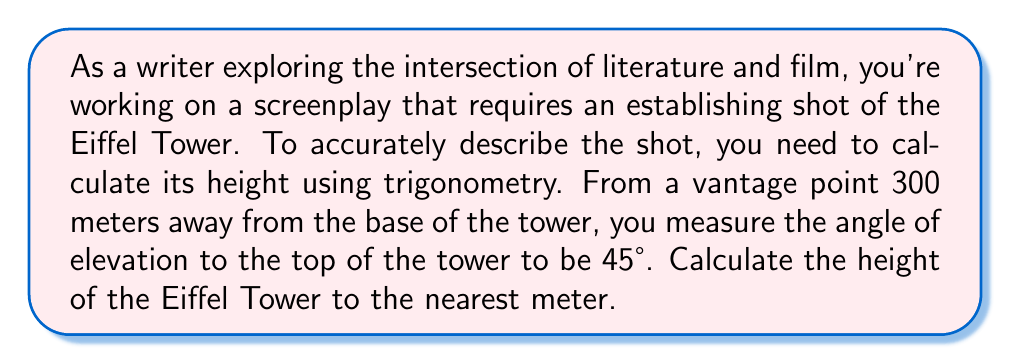Can you answer this question? Let's approach this step-by-step using trigonometry:

1) First, let's visualize the problem:

[asy]
unitsize(0.01cm);
draw((0,0)--(300,0)--(300,300)--(0,0),black);
draw((0,0)--(0,300),dashed);
label("300 m", (150,0), S);
label("45°", (20,20), NW);
label("h", (305,150), E);
label("Eiffel Tower", (0,150), W);
[/asy]

2) We have a right-angled triangle where:
   - The adjacent side is 300 meters (distance from the vantage point to the base)
   - The angle of elevation is 45°
   - We need to find the opposite side (height of the tower)

3) In this scenario, we can use the tangent function:

   $$\tan(\theta) = \frac{\text{opposite}}{\text{adjacent}}$$

4) Substituting our known values:

   $$\tan(45°) = \frac{h}{300}$$

5) We know that $\tan(45°) = 1$, so:

   $$1 = \frac{h}{300}$$

6) Solving for h:

   $$h = 300 \times 1 = 300$$

7) Therefore, the height of the Eiffel Tower is 300 meters.

Note: The actual height of the Eiffel Tower is about 324 meters, but this calculation gives us a good approximation for an establishing shot description.
Answer: 300 meters 